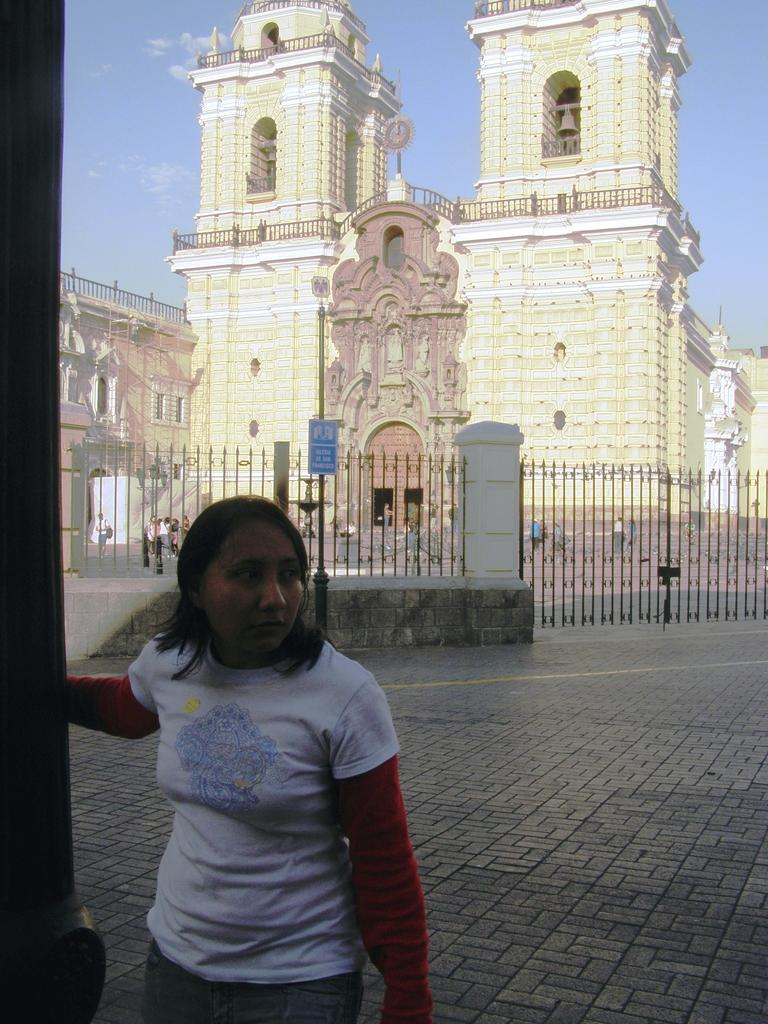Who is the main subject in the foreground of the image? There is a woman in the foreground of the image. Where is the woman located in the image? The woman is on the road. What can be seen in the background of the image? There is a fence, a crowd, and a fort in the background of the image. What is visible at the top of the image? The sky is visible at the top of the image. When was the image taken? The image was taken during the day. What type of metal is the woman using to clear her throat in the image? There is no indication in the image that the woman is using any metal or clearing her throat. 